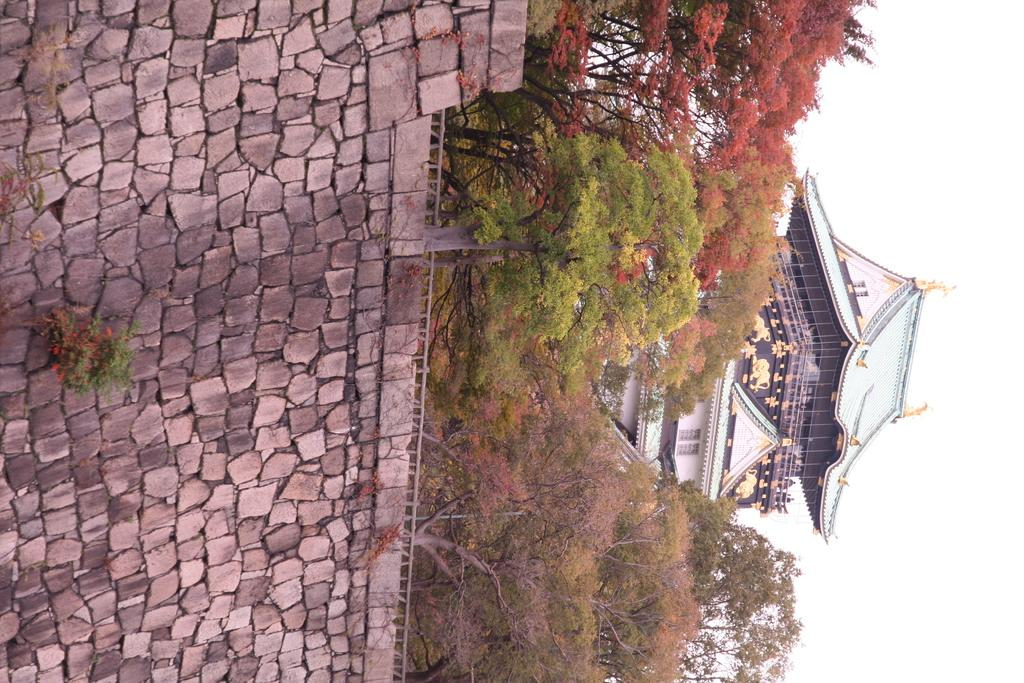What type of structure is present in the image? There is a building in the image. What is located in front of the building? There is a group of trees in front of the building. What can be seen on the left side? There is a wall on the left side of the image. What is near the wall in the image? There are plants near the wall. What is visible on the right side of the image? The sky is visible on the right side of the image. What type of spark can be seen comforting the building in the image? There is no spark present in the image, and the building does not require comforting. 